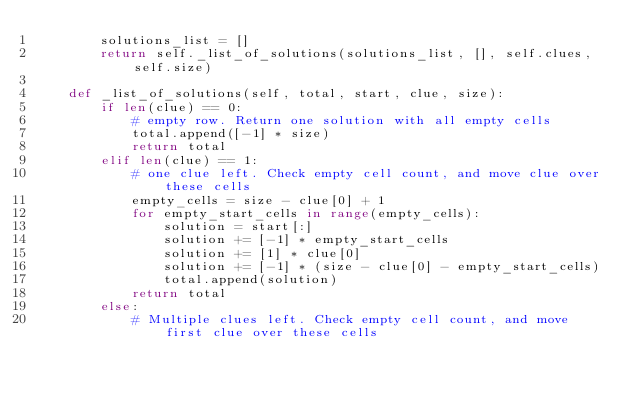<code> <loc_0><loc_0><loc_500><loc_500><_Python_>        solutions_list = []
        return self._list_of_solutions(solutions_list, [], self.clues, self.size)

    def _list_of_solutions(self, total, start, clue, size):
        if len(clue) == 0:
            # empty row. Return one solution with all empty cells
            total.append([-1] * size)
            return total
        elif len(clue) == 1:
            # one clue left. Check empty cell count, and move clue over these cells
            empty_cells = size - clue[0] + 1
            for empty_start_cells in range(empty_cells):
                solution = start[:]
                solution += [-1] * empty_start_cells
                solution += [1] * clue[0]
                solution += [-1] * (size - clue[0] - empty_start_cells)
                total.append(solution)
            return total
        else:
            # Multiple clues left. Check empty cell count, and move first clue over these cells</code> 